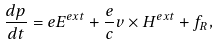Convert formula to latex. <formula><loc_0><loc_0><loc_500><loc_500>\frac { d { p } } { d t } = e { E ^ { e x t } } + \frac { e } { c } { v } \times { H ^ { e x t } } + { f } _ { R } ,</formula> 